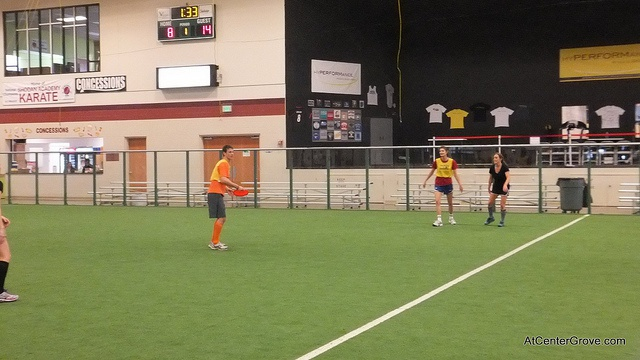Describe the objects in this image and their specific colors. I can see bench in gray and tan tones, clock in gray, maroon, tan, and darkgray tones, people in gray, red, salmon, tan, and black tones, people in gray, maroon, brown, tan, and orange tones, and people in gray, black, brown, and maroon tones in this image. 